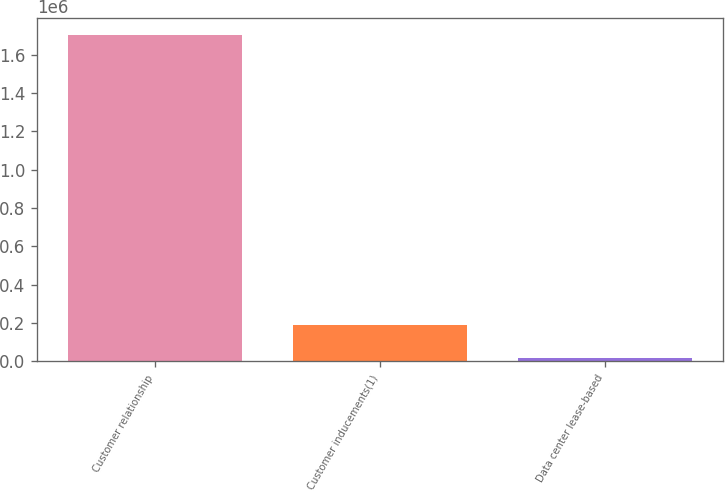<chart> <loc_0><loc_0><loc_500><loc_500><bar_chart><fcel>Customer relationship<fcel>Customer inducements(1)<fcel>Data center lease-based<nl><fcel>1.7041e+06<fcel>187793<fcel>19314<nl></chart> 